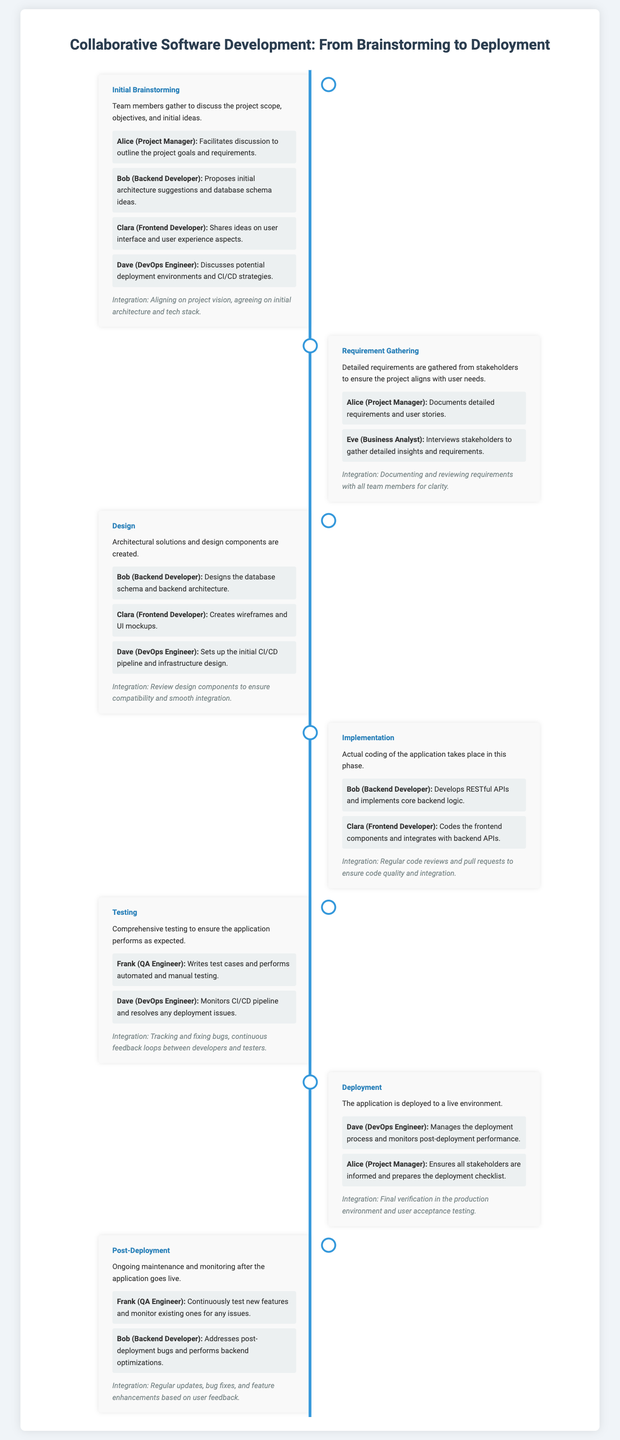What is the first phase of the project? The first phase listed in the timeline infographic is "Initial Brainstorming."
Answer: Initial Brainstorming Who is responsible for writing test cases? The document states that Frank (QA Engineer) writes test cases and performs testing.
Answer: Frank (QA Engineer) Which team member proposed initial architecture suggestions? According to the infographic, Bob (Backend Developer) proposed initial architecture suggestions.
Answer: Bob (Backend Developer) How many phases are detailed in the timeline? The timeline infographic details six phases of the project.
Answer: Six What was the focus of the "Requirement Gathering" phase? The focus of the "Requirement Gathering" phase was to gather detailed requirements from stakeholders.
Answer: Gather detailed requirements During which phase is user acceptance testing conducted? The infographic mentions user acceptance testing is conducted during the "Deployment" phase.
Answer: Deployment Who discusses potential deployment environments? The document states that Dave (DevOps Engineer) discusses potential deployment environments.
Answer: Dave (DevOps Engineer) What is the purpose of the "Design" phase? The "Design" phase is for creating architectural solutions and design components.
Answer: Creating architectural solutions Which phase involves coding the application? The phase where actual coding of the application takes place is called "Implementation."
Answer: Implementation What role does Eve have in the project? Eve's role in the project is listed as a Business Analyst.
Answer: Business Analyst 